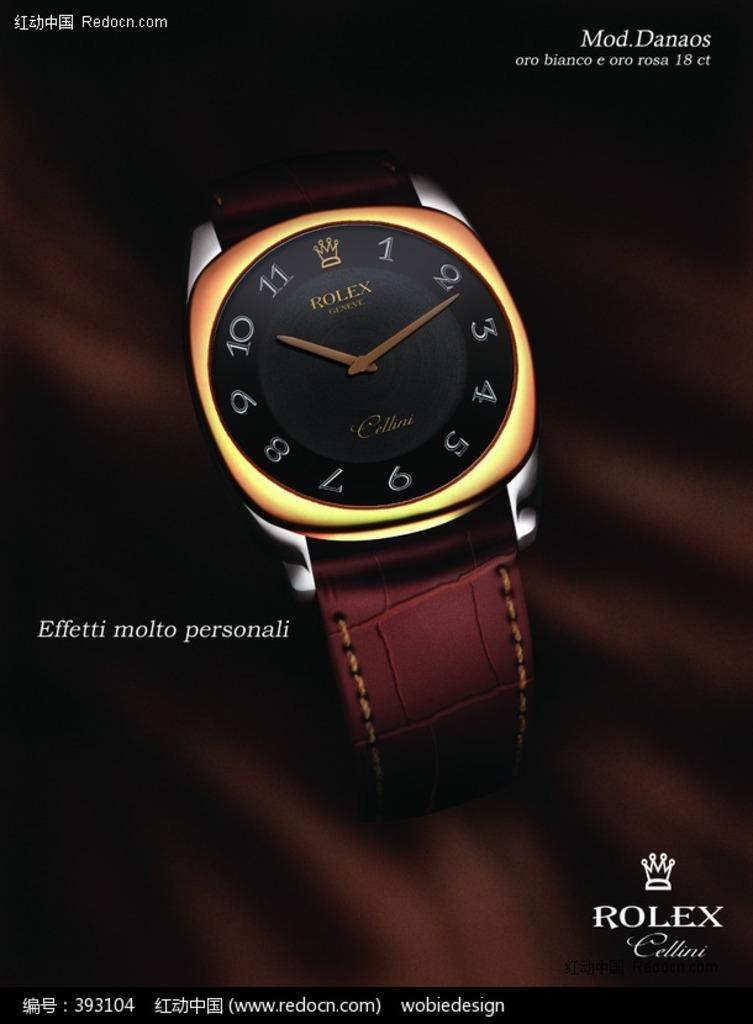What brand of watch is this?
Offer a terse response. Rolex. What time does the watch show?
Your response must be concise. 10:11. 